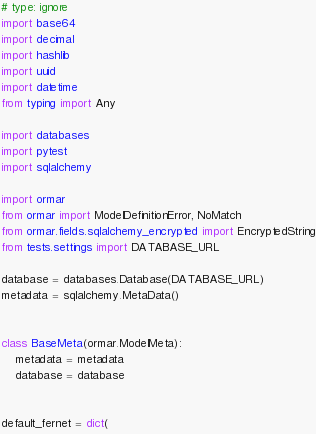Convert code to text. <code><loc_0><loc_0><loc_500><loc_500><_Python_># type: ignore
import base64
import decimal
import hashlib
import uuid
import datetime
from typing import Any

import databases
import pytest
import sqlalchemy

import ormar
from ormar import ModelDefinitionError, NoMatch
from ormar.fields.sqlalchemy_encrypted import EncryptedString
from tests.settings import DATABASE_URL

database = databases.Database(DATABASE_URL)
metadata = sqlalchemy.MetaData()


class BaseMeta(ormar.ModelMeta):
    metadata = metadata
    database = database


default_fernet = dict(</code> 